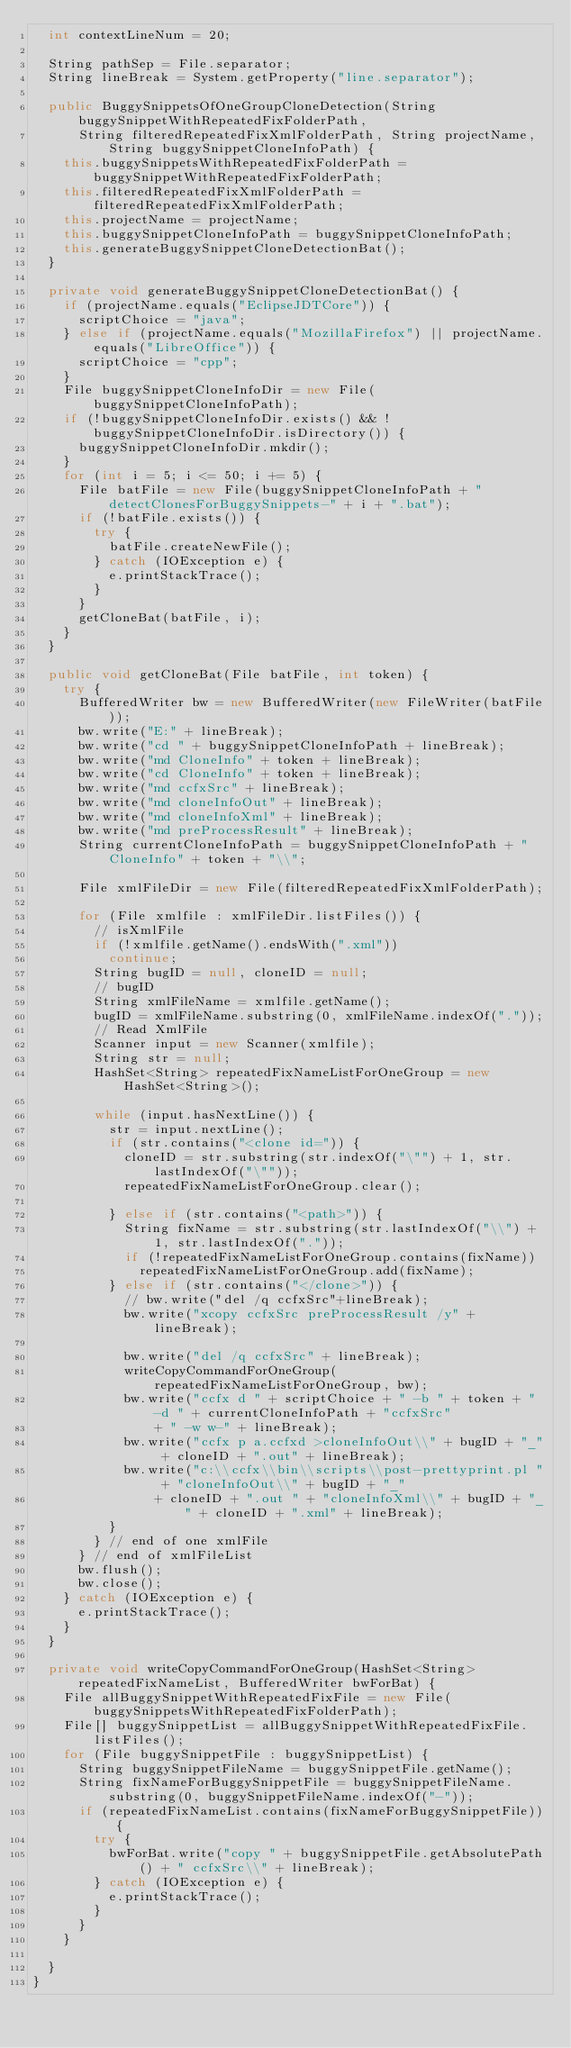<code> <loc_0><loc_0><loc_500><loc_500><_Java_>	int contextLineNum = 20;

	String pathSep = File.separator;
	String lineBreak = System.getProperty("line.separator");

	public BuggySnippetsOfOneGroupCloneDetection(String buggySnippetWithRepeatedFixFolderPath,
			String filteredRepeatedFixXmlFolderPath, String projectName, String buggySnippetCloneInfoPath) {
		this.buggySnippetsWithRepeatedFixFolderPath = buggySnippetWithRepeatedFixFolderPath;
		this.filteredRepeatedFixXmlFolderPath = filteredRepeatedFixXmlFolderPath;
		this.projectName = projectName;
		this.buggySnippetCloneInfoPath = buggySnippetCloneInfoPath;
		this.generateBuggySnippetCloneDetectionBat();
	}

	private void generateBuggySnippetCloneDetectionBat() {
		if (projectName.equals("EclipseJDTCore")) {
			scriptChoice = "java";
		} else if (projectName.equals("MozillaFirefox") || projectName.equals("LibreOffice")) {
			scriptChoice = "cpp";
		}
		File buggySnippetCloneInfoDir = new File(buggySnippetCloneInfoPath);
		if (!buggySnippetCloneInfoDir.exists() && !buggySnippetCloneInfoDir.isDirectory()) {
			buggySnippetCloneInfoDir.mkdir();
		}
		for (int i = 5; i <= 50; i += 5) {
			File batFile = new File(buggySnippetCloneInfoPath + "detectClonesForBuggySnippets-" + i + ".bat");
			if (!batFile.exists()) {
				try {
					batFile.createNewFile();
				} catch (IOException e) {
					e.printStackTrace();
				}
			}
			getCloneBat(batFile, i);
		}
	}

	public void getCloneBat(File batFile, int token) {
		try {
			BufferedWriter bw = new BufferedWriter(new FileWriter(batFile));
			bw.write("E:" + lineBreak);
			bw.write("cd " + buggySnippetCloneInfoPath + lineBreak);
			bw.write("md CloneInfo" + token + lineBreak);
			bw.write("cd CloneInfo" + token + lineBreak);
			bw.write("md ccfxSrc" + lineBreak);
			bw.write("md cloneInfoOut" + lineBreak);
			bw.write("md cloneInfoXml" + lineBreak);
			bw.write("md preProcessResult" + lineBreak);
			String currentCloneInfoPath = buggySnippetCloneInfoPath + "CloneInfo" + token + "\\";

			File xmlFileDir = new File(filteredRepeatedFixXmlFolderPath);

			for (File xmlfile : xmlFileDir.listFiles()) {
				// isXmlFile
				if (!xmlfile.getName().endsWith(".xml"))
					continue;
				String bugID = null, cloneID = null;
				// bugID
				String xmlFileName = xmlfile.getName();
				bugID = xmlFileName.substring(0, xmlFileName.indexOf("."));
				// Read XmlFile
				Scanner input = new Scanner(xmlfile);
				String str = null;
				HashSet<String> repeatedFixNameListForOneGroup = new HashSet<String>();

				while (input.hasNextLine()) {
					str = input.nextLine();
					if (str.contains("<clone id=")) {
						cloneID = str.substring(str.indexOf("\"") + 1, str.lastIndexOf("\""));
						repeatedFixNameListForOneGroup.clear();

					} else if (str.contains("<path>")) {
						String fixName = str.substring(str.lastIndexOf("\\") + 1, str.lastIndexOf("."));
						if (!repeatedFixNameListForOneGroup.contains(fixName))
							repeatedFixNameListForOneGroup.add(fixName);
					} else if (str.contains("</clone>")) {
						// bw.write("del /q ccfxSrc"+lineBreak);
						bw.write("xcopy ccfxSrc preProcessResult /y" + lineBreak);

						bw.write("del /q ccfxSrc" + lineBreak);
						writeCopyCommandForOneGroup(repeatedFixNameListForOneGroup, bw);
						bw.write("ccfx d " + scriptChoice + " -b " + token + " -d " + currentCloneInfoPath + "ccfxSrc"
								+ " -w w-" + lineBreak);
						bw.write("ccfx p a.ccfxd >cloneInfoOut\\" + bugID + "_" + cloneID + ".out" + lineBreak);
						bw.write("c:\\ccfx\\bin\\scripts\\post-prettyprint.pl " + "cloneInfoOut\\" + bugID + "_"
								+ cloneID + ".out " + "cloneInfoXml\\" + bugID + "_" + cloneID + ".xml" + lineBreak);
					}
				} // end of one xmlFile
			} // end of xmlFileList
			bw.flush();
			bw.close();
		} catch (IOException e) {
			e.printStackTrace();
		}
	}

	private void writeCopyCommandForOneGroup(HashSet<String> repeatedFixNameList, BufferedWriter bwForBat) {
		File allBuggySnippetWithRepeatedFixFile = new File(buggySnippetsWithRepeatedFixFolderPath);
		File[] buggySnippetList = allBuggySnippetWithRepeatedFixFile.listFiles();
		for (File buggySnippetFile : buggySnippetList) {
			String buggySnippetFileName = buggySnippetFile.getName();
			String fixNameForBuggySnippetFile = buggySnippetFileName.substring(0, buggySnippetFileName.indexOf("-"));
			if (repeatedFixNameList.contains(fixNameForBuggySnippetFile)) {
				try {
					bwForBat.write("copy " + buggySnippetFile.getAbsolutePath() + " ccfxSrc\\" + lineBreak);
				} catch (IOException e) {
					e.printStackTrace();
				}
			}
		}

	}
}
</code> 